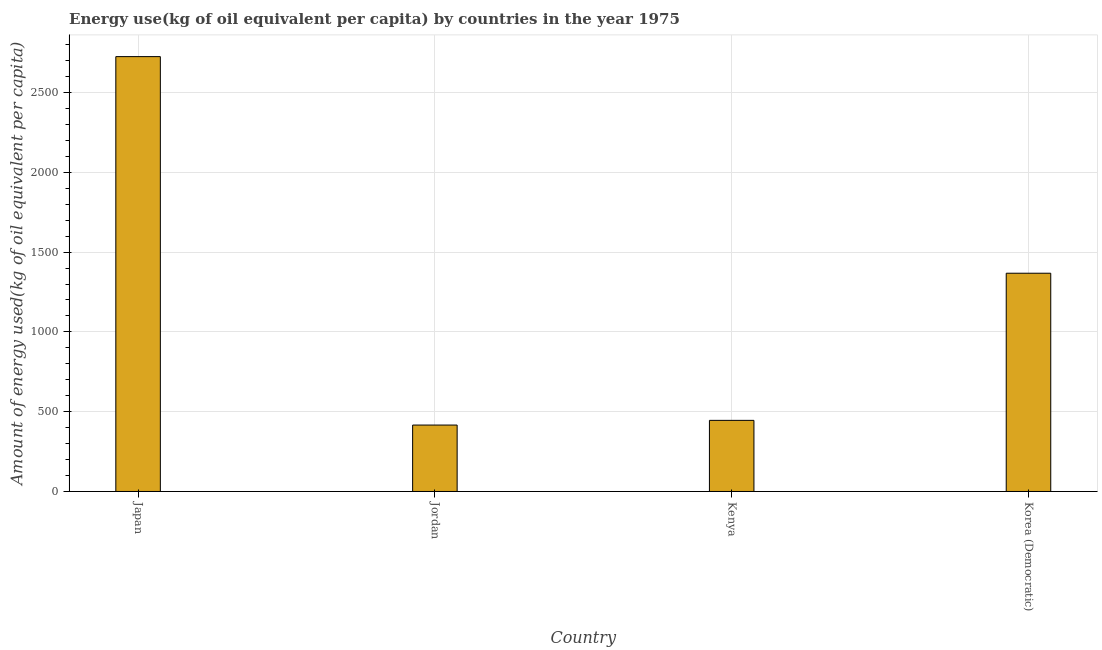Does the graph contain grids?
Provide a short and direct response. Yes. What is the title of the graph?
Provide a succinct answer. Energy use(kg of oil equivalent per capita) by countries in the year 1975. What is the label or title of the X-axis?
Provide a succinct answer. Country. What is the label or title of the Y-axis?
Your answer should be very brief. Amount of energy used(kg of oil equivalent per capita). What is the amount of energy used in Japan?
Give a very brief answer. 2725.16. Across all countries, what is the maximum amount of energy used?
Keep it short and to the point. 2725.16. Across all countries, what is the minimum amount of energy used?
Ensure brevity in your answer.  416.21. In which country was the amount of energy used minimum?
Your response must be concise. Jordan. What is the sum of the amount of energy used?
Your answer should be compact. 4954.73. What is the difference between the amount of energy used in Japan and Jordan?
Ensure brevity in your answer.  2308.95. What is the average amount of energy used per country?
Keep it short and to the point. 1238.68. What is the median amount of energy used?
Ensure brevity in your answer.  906.68. What is the ratio of the amount of energy used in Japan to that in Jordan?
Your answer should be compact. 6.55. Is the amount of energy used in Jordan less than that in Kenya?
Keep it short and to the point. Yes. Is the difference between the amount of energy used in Jordan and Korea (Democratic) greater than the difference between any two countries?
Your answer should be very brief. No. What is the difference between the highest and the second highest amount of energy used?
Give a very brief answer. 1357.45. What is the difference between the highest and the lowest amount of energy used?
Offer a terse response. 2308.95. How many bars are there?
Give a very brief answer. 4. Are all the bars in the graph horizontal?
Offer a terse response. No. How many countries are there in the graph?
Provide a succinct answer. 4. What is the difference between two consecutive major ticks on the Y-axis?
Provide a succinct answer. 500. Are the values on the major ticks of Y-axis written in scientific E-notation?
Provide a short and direct response. No. What is the Amount of energy used(kg of oil equivalent per capita) in Japan?
Offer a very short reply. 2725.16. What is the Amount of energy used(kg of oil equivalent per capita) of Jordan?
Provide a short and direct response. 416.21. What is the Amount of energy used(kg of oil equivalent per capita) of Kenya?
Provide a short and direct response. 445.65. What is the Amount of energy used(kg of oil equivalent per capita) of Korea (Democratic)?
Ensure brevity in your answer.  1367.71. What is the difference between the Amount of energy used(kg of oil equivalent per capita) in Japan and Jordan?
Provide a succinct answer. 2308.95. What is the difference between the Amount of energy used(kg of oil equivalent per capita) in Japan and Kenya?
Provide a short and direct response. 2279.51. What is the difference between the Amount of energy used(kg of oil equivalent per capita) in Japan and Korea (Democratic)?
Keep it short and to the point. 1357.45. What is the difference between the Amount of energy used(kg of oil equivalent per capita) in Jordan and Kenya?
Provide a short and direct response. -29.44. What is the difference between the Amount of energy used(kg of oil equivalent per capita) in Jordan and Korea (Democratic)?
Your answer should be very brief. -951.5. What is the difference between the Amount of energy used(kg of oil equivalent per capita) in Kenya and Korea (Democratic)?
Ensure brevity in your answer.  -922.06. What is the ratio of the Amount of energy used(kg of oil equivalent per capita) in Japan to that in Jordan?
Provide a succinct answer. 6.55. What is the ratio of the Amount of energy used(kg of oil equivalent per capita) in Japan to that in Kenya?
Provide a short and direct response. 6.12. What is the ratio of the Amount of energy used(kg of oil equivalent per capita) in Japan to that in Korea (Democratic)?
Ensure brevity in your answer.  1.99. What is the ratio of the Amount of energy used(kg of oil equivalent per capita) in Jordan to that in Kenya?
Keep it short and to the point. 0.93. What is the ratio of the Amount of energy used(kg of oil equivalent per capita) in Jordan to that in Korea (Democratic)?
Give a very brief answer. 0.3. What is the ratio of the Amount of energy used(kg of oil equivalent per capita) in Kenya to that in Korea (Democratic)?
Provide a short and direct response. 0.33. 